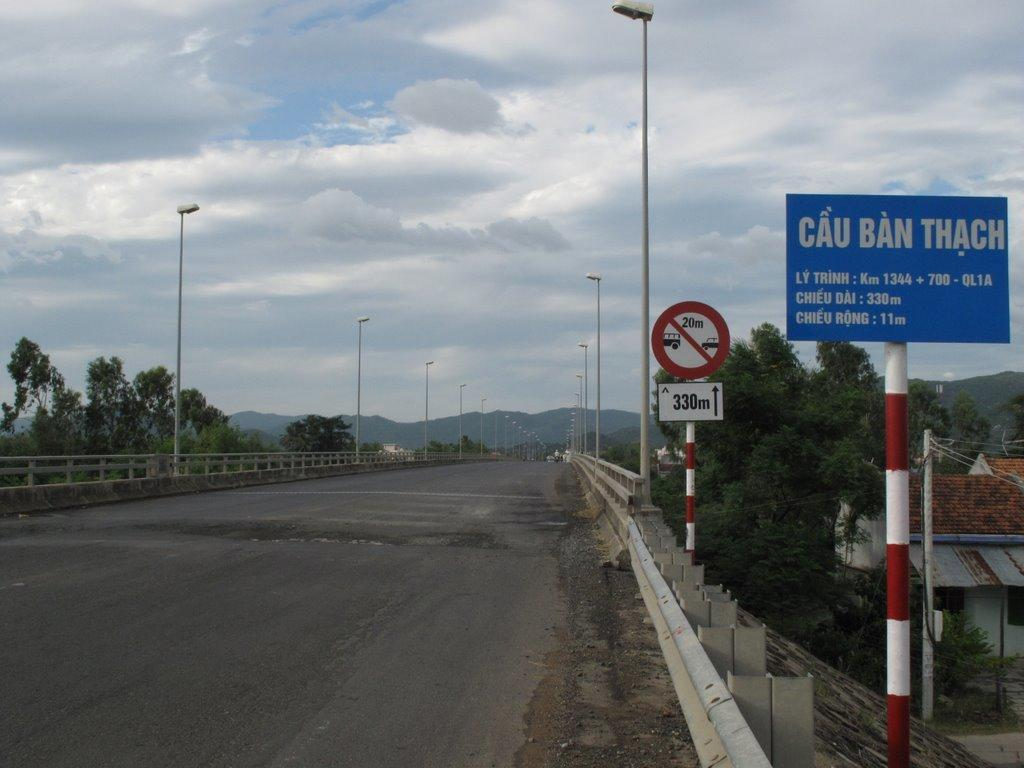Provide a one-sentence caption for the provided image. A blue road sign on the right that says Cau Ban Thach. 